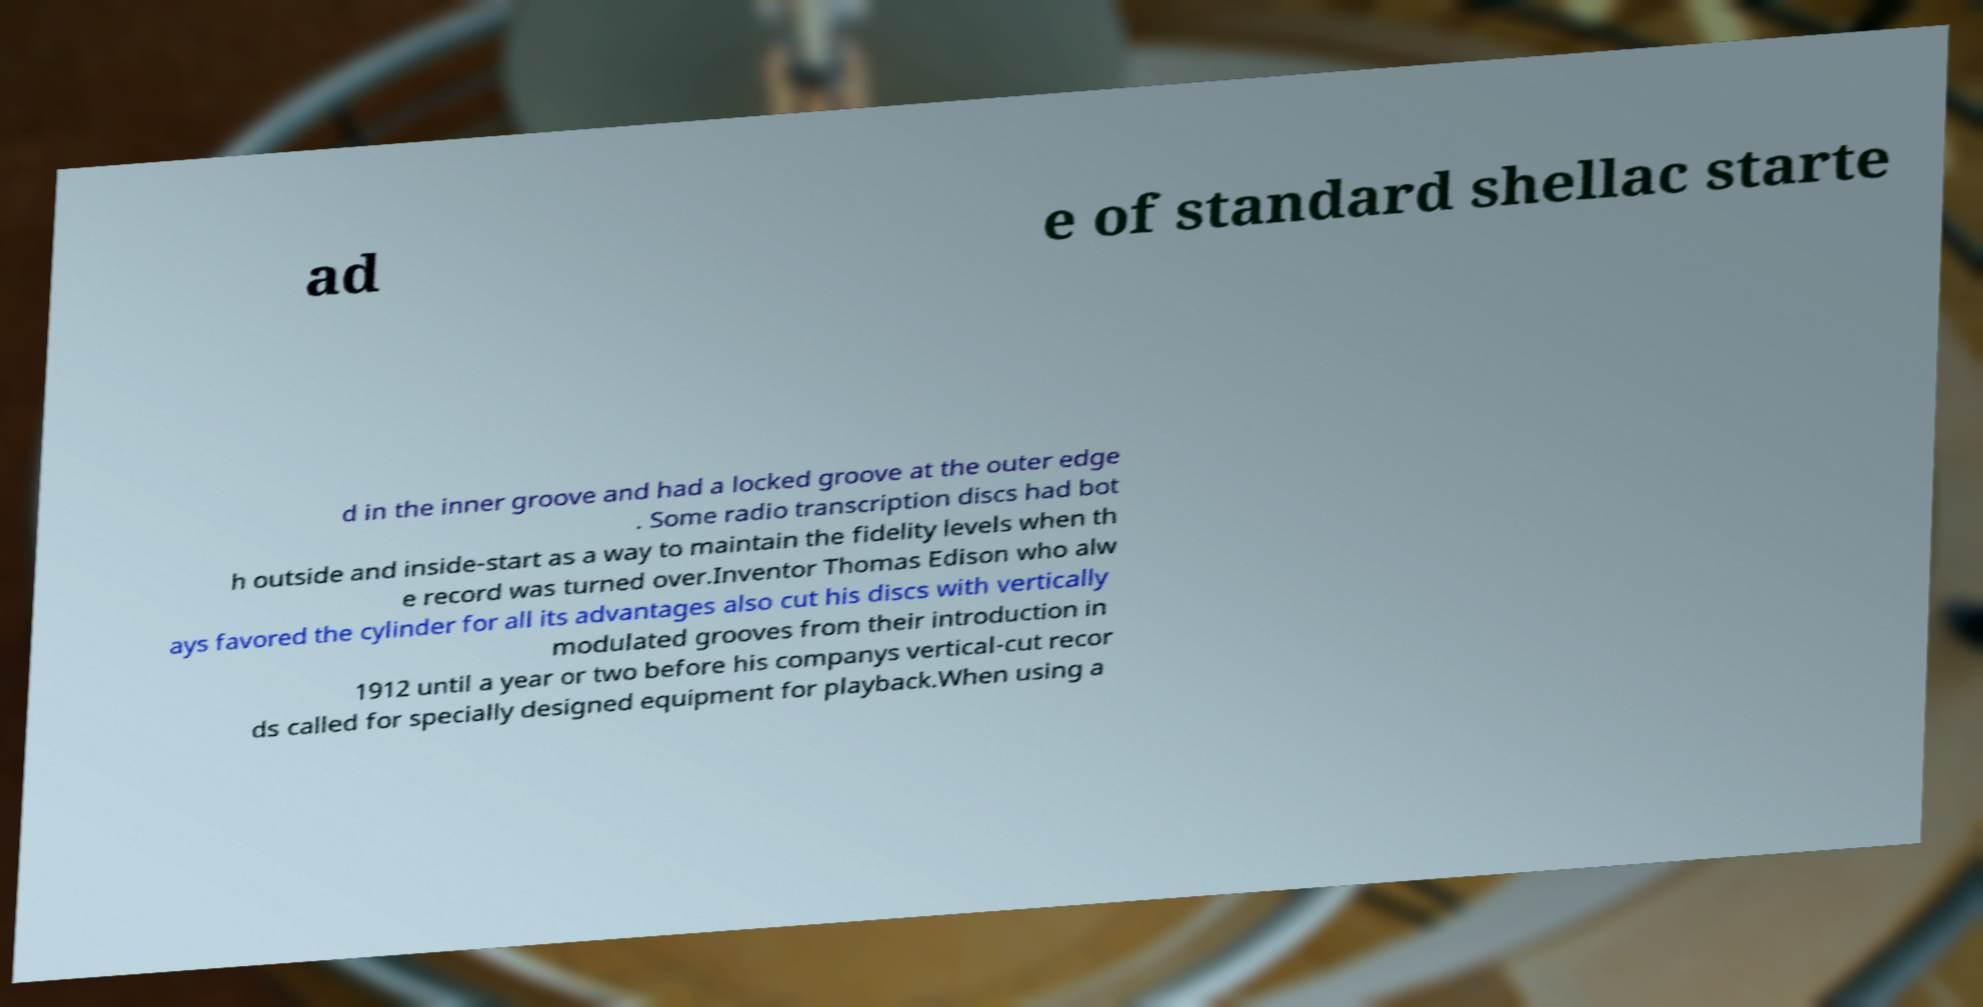Could you assist in decoding the text presented in this image and type it out clearly? ad e of standard shellac starte d in the inner groove and had a locked groove at the outer edge . Some radio transcription discs had bot h outside and inside-start as a way to maintain the fidelity levels when th e record was turned over.Inventor Thomas Edison who alw ays favored the cylinder for all its advantages also cut his discs with vertically modulated grooves from their introduction in 1912 until a year or two before his companys vertical-cut recor ds called for specially designed equipment for playback.When using a 